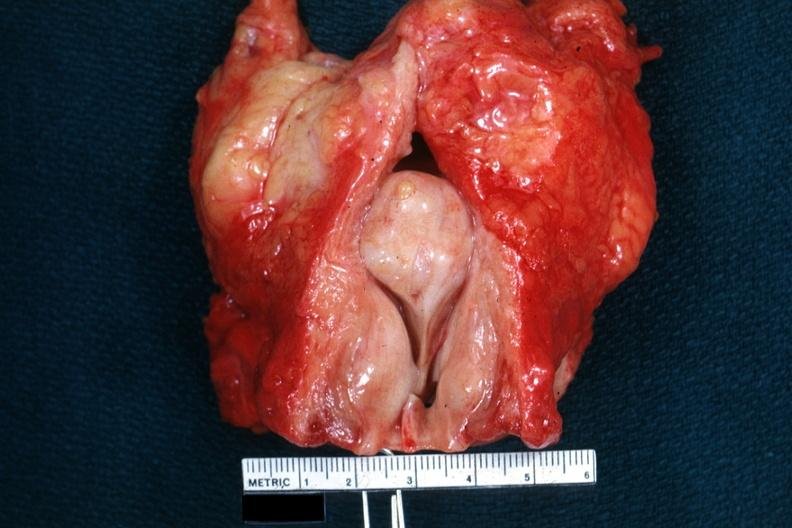what does this image show?
Answer the question using a single word or phrase. Large medial lobar so-called median bar not show bladder well 